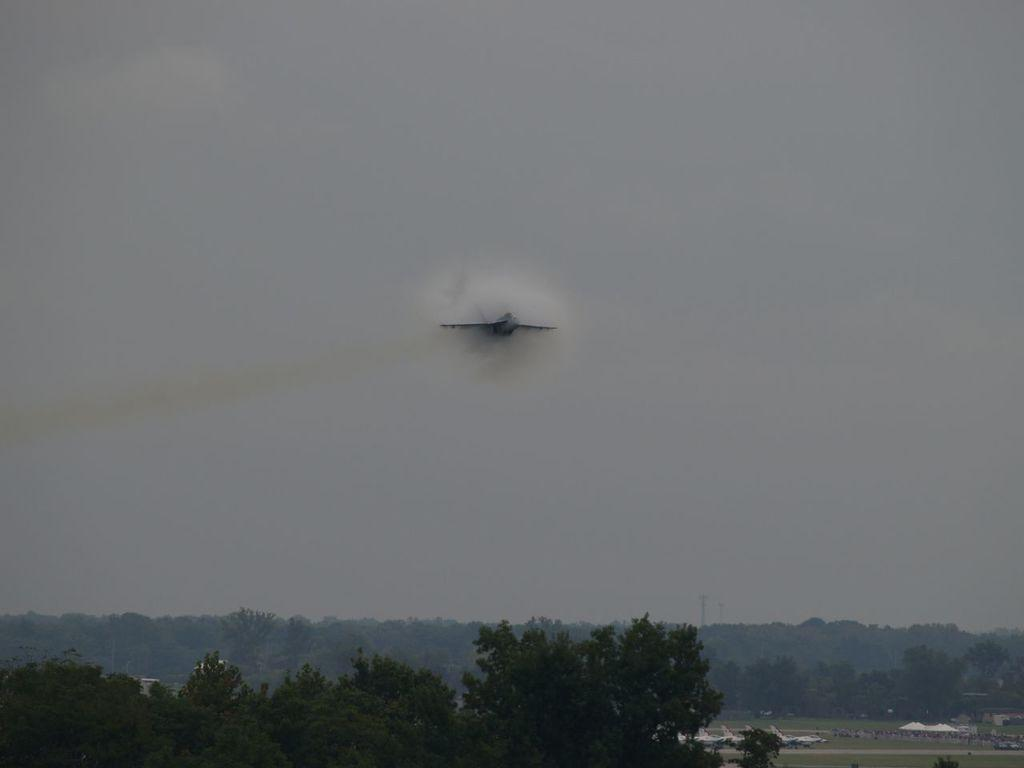What type of vegetation can be seen in the image? There are trees, plants, and grass in the image. What part of the natural environment is visible in the image? The sky is visible in the image. How many pigs can be seen in the image? There are no pigs present in the image. What type of bell is hanging from the tree in the image? There is no bell present in the image. 